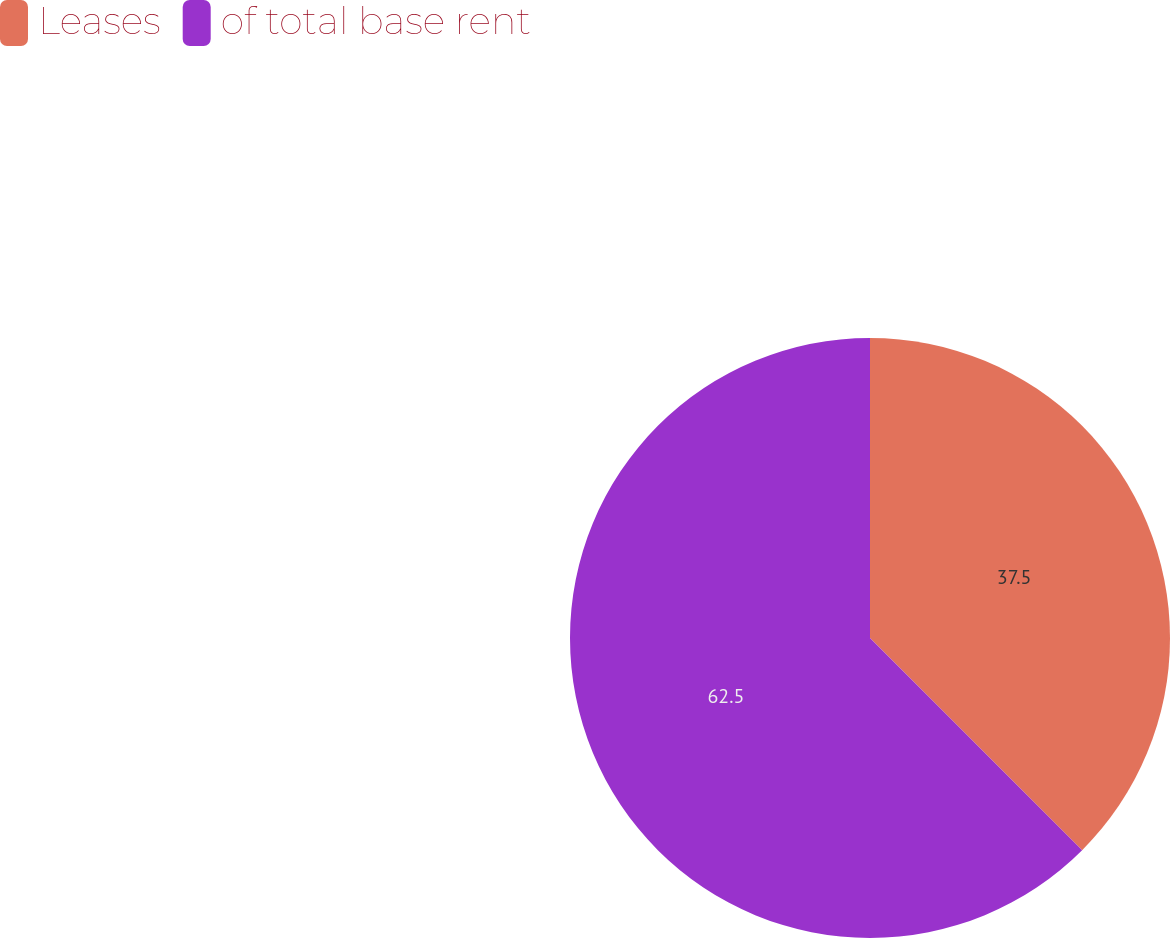Convert chart to OTSL. <chart><loc_0><loc_0><loc_500><loc_500><pie_chart><fcel>Leases<fcel>of total base rent<nl><fcel>37.5%<fcel>62.5%<nl></chart> 